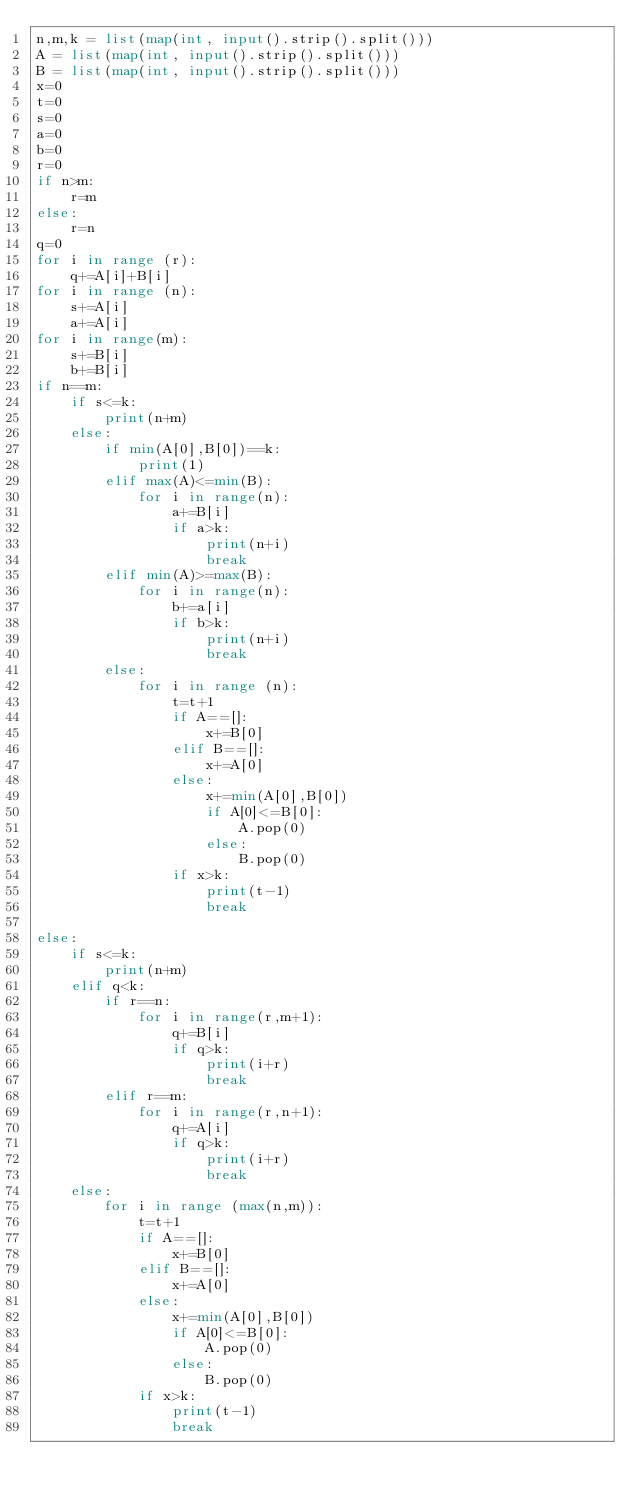Convert code to text. <code><loc_0><loc_0><loc_500><loc_500><_Python_>n,m,k = list(map(int, input().strip().split()))
A = list(map(int, input().strip().split()))
B = list(map(int, input().strip().split()))
x=0
t=0
s=0
a=0
b=0
r=0
if n>m:
    r=m
else:
    r=n
q=0
for i in range (r):
    q+=A[i]+B[i]
for i in range (n):
    s+=A[i]
    a+=A[i]
for i in range(m):
    s+=B[i]
    b+=B[i]
if n==m:
    if s<=k:
        print(n+m)
    else:
        if min(A[0],B[0])==k:
            print(1)
        elif max(A)<=min(B):
            for i in range(n):
                a+=B[i]
                if a>k:
                    print(n+i)
                    break
        elif min(A)>=max(B):
            for i in range(n):
                b+=a[i]
                if b>k:
                    print(n+i)
                    break
        else:
            for i in range (n):
                t=t+1
                if A==[]:
                    x+=B[0]
                elif B==[]:
                    x+=A[0]
                else:    
                    x+=min(A[0],B[0])
                    if A[0]<=B[0]:
                        A.pop(0)
                    else:
                        B.pop(0)
                if x>k:
                    print(t-1)
                    break
        
else:
    if s<=k:
        print(n+m)
    elif q<k:
        if r==n:
            for i in range(r,m+1):
                q+=B[i]
                if q>k:
                    print(i+r)
                    break
        elif r==m:
            for i in range(r,n+1):
                q+=A[i]
                if q>k:
                    print(i+r)
                    break
    else:
        for i in range (max(n,m)):
            t=t+1
            if A==[]:
                x+=B[0]
            elif B==[]:
                x+=A[0]
            else:    
                x+=min(A[0],B[0])
                if A[0]<=B[0]:
                    A.pop(0)
                else:
                    B.pop(0)
            if x>k:
                print(t-1)
                break
</code> 